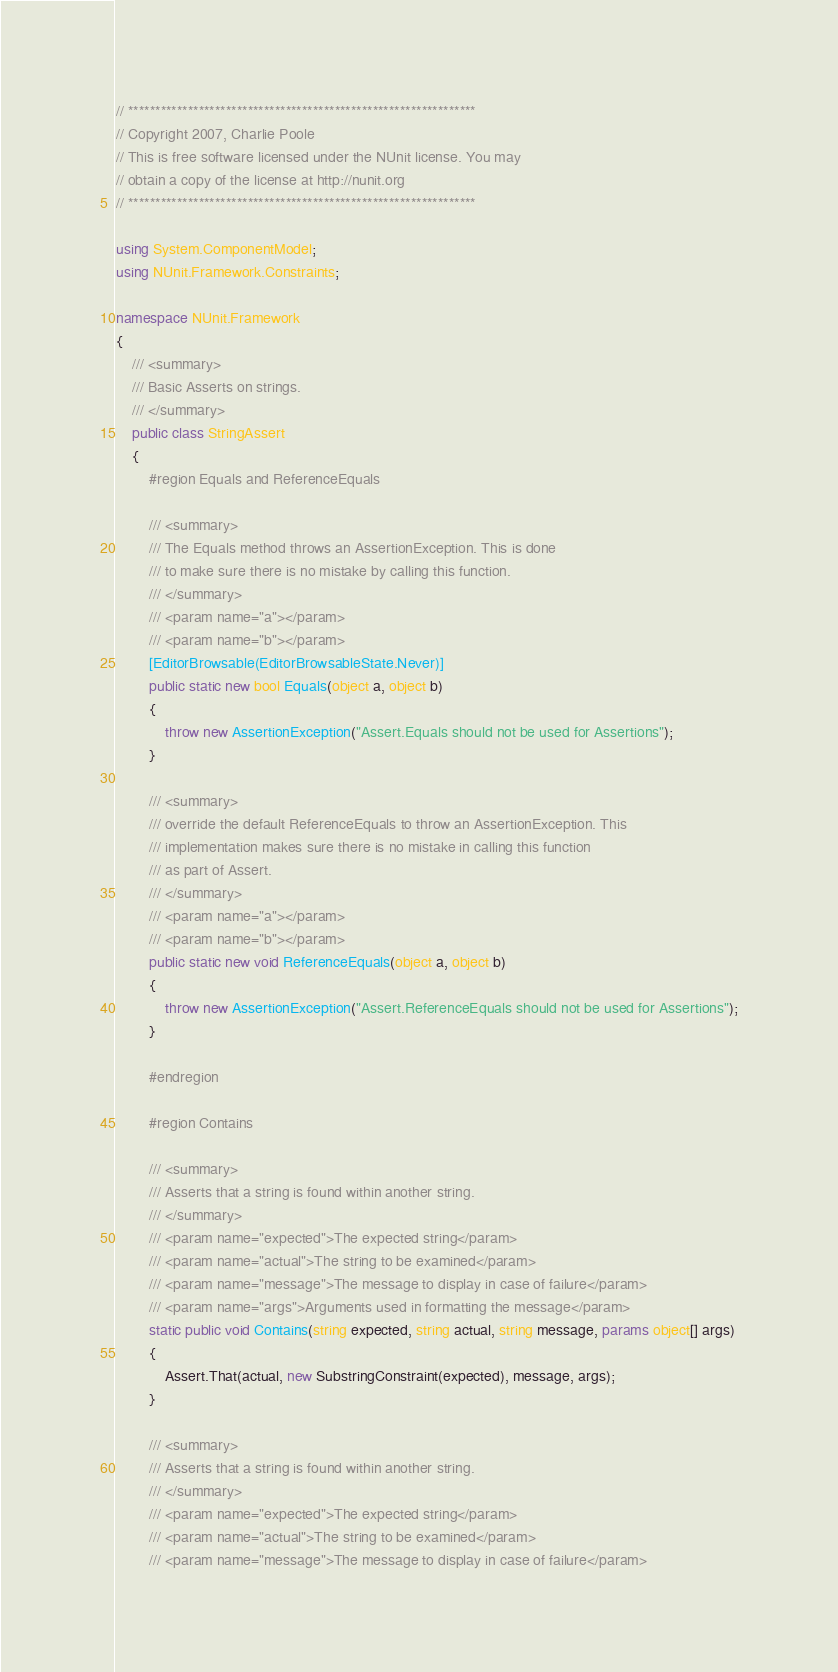Convert code to text. <code><loc_0><loc_0><loc_500><loc_500><_C#_>// ****************************************************************
// Copyright 2007, Charlie Poole
// This is free software licensed under the NUnit license. You may
// obtain a copy of the license at http://nunit.org
// ****************************************************************

using System.ComponentModel;
using NUnit.Framework.Constraints;

namespace NUnit.Framework
{
	/// <summary>
	/// Basic Asserts on strings.
	/// </summary>
	public class StringAssert
	{
		#region Equals and ReferenceEquals

		/// <summary>
		/// The Equals method throws an AssertionException. This is done 
		/// to make sure there is no mistake by calling this function.
		/// </summary>
		/// <param name="a"></param>
		/// <param name="b"></param>
		[EditorBrowsable(EditorBrowsableState.Never)]
		public static new bool Equals(object a, object b)
		{
			throw new AssertionException("Assert.Equals should not be used for Assertions");
		}

		/// <summary>
		/// override the default ReferenceEquals to throw an AssertionException. This 
		/// implementation makes sure there is no mistake in calling this function 
		/// as part of Assert. 
		/// </summary>
		/// <param name="a"></param>
		/// <param name="b"></param>
		public static new void ReferenceEquals(object a, object b)
		{
			throw new AssertionException("Assert.ReferenceEquals should not be used for Assertions");
		}

		#endregion

        #region Contains

        /// <summary>
        /// Asserts that a string is found within another string.
        /// </summary>
        /// <param name="expected">The expected string</param>
        /// <param name="actual">The string to be examined</param>
        /// <param name="message">The message to display in case of failure</param>
        /// <param name="args">Arguments used in formatting the message</param>
        static public void Contains(string expected, string actual, string message, params object[] args)
        {
            Assert.That(actual, new SubstringConstraint(expected), message, args);
        }

        /// <summary>
        /// Asserts that a string is found within another string.
        /// </summary>
        /// <param name="expected">The expected string</param>
        /// <param name="actual">The string to be examined</param>
        /// <param name="message">The message to display in case of failure</param></code> 